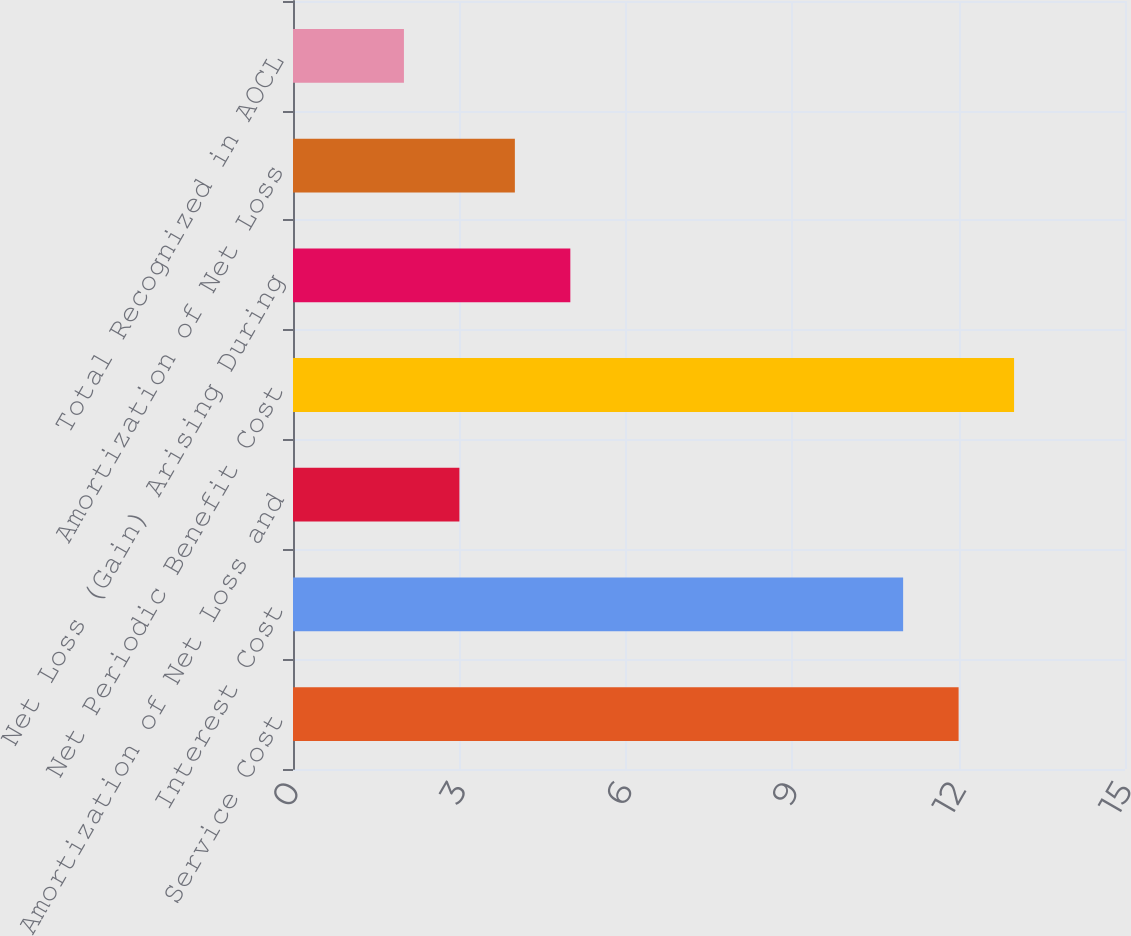<chart> <loc_0><loc_0><loc_500><loc_500><bar_chart><fcel>Service Cost<fcel>Interest Cost<fcel>Amortization of Net Loss and<fcel>Net Periodic Benefit Cost<fcel>Net Loss (Gain) Arising During<fcel>Amortization of Net Loss<fcel>Total Recognized in AOCL<nl><fcel>12<fcel>11<fcel>3<fcel>13<fcel>5<fcel>4<fcel>2<nl></chart> 